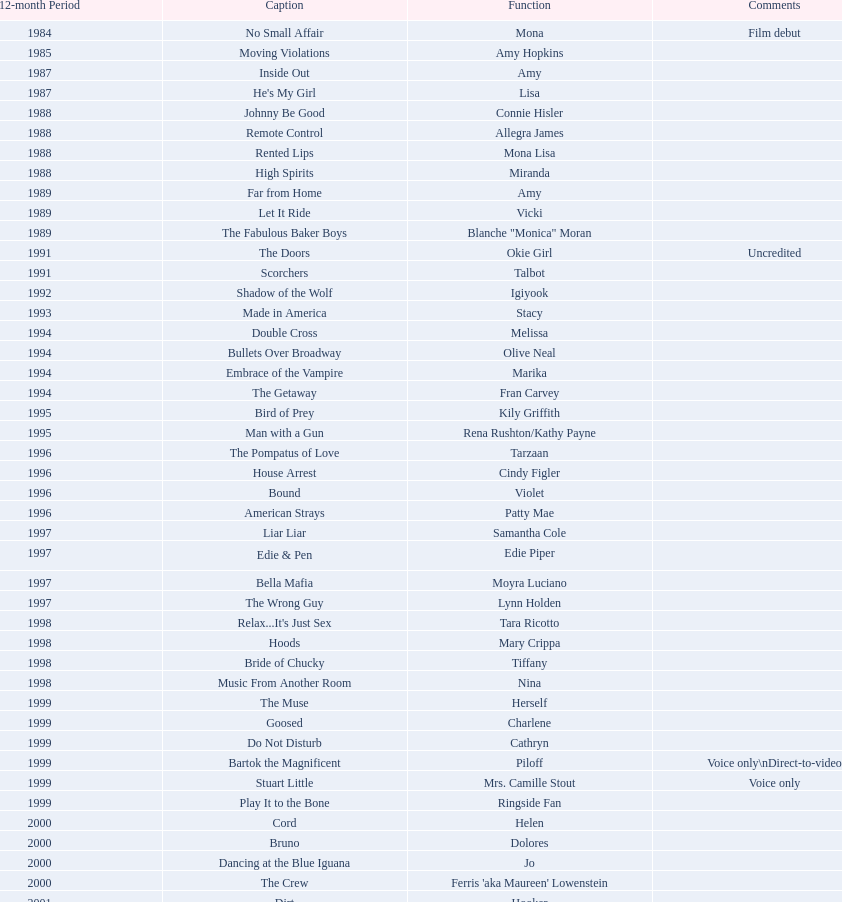How many rolls did jennifer tilly play in the 1980s? 11. 